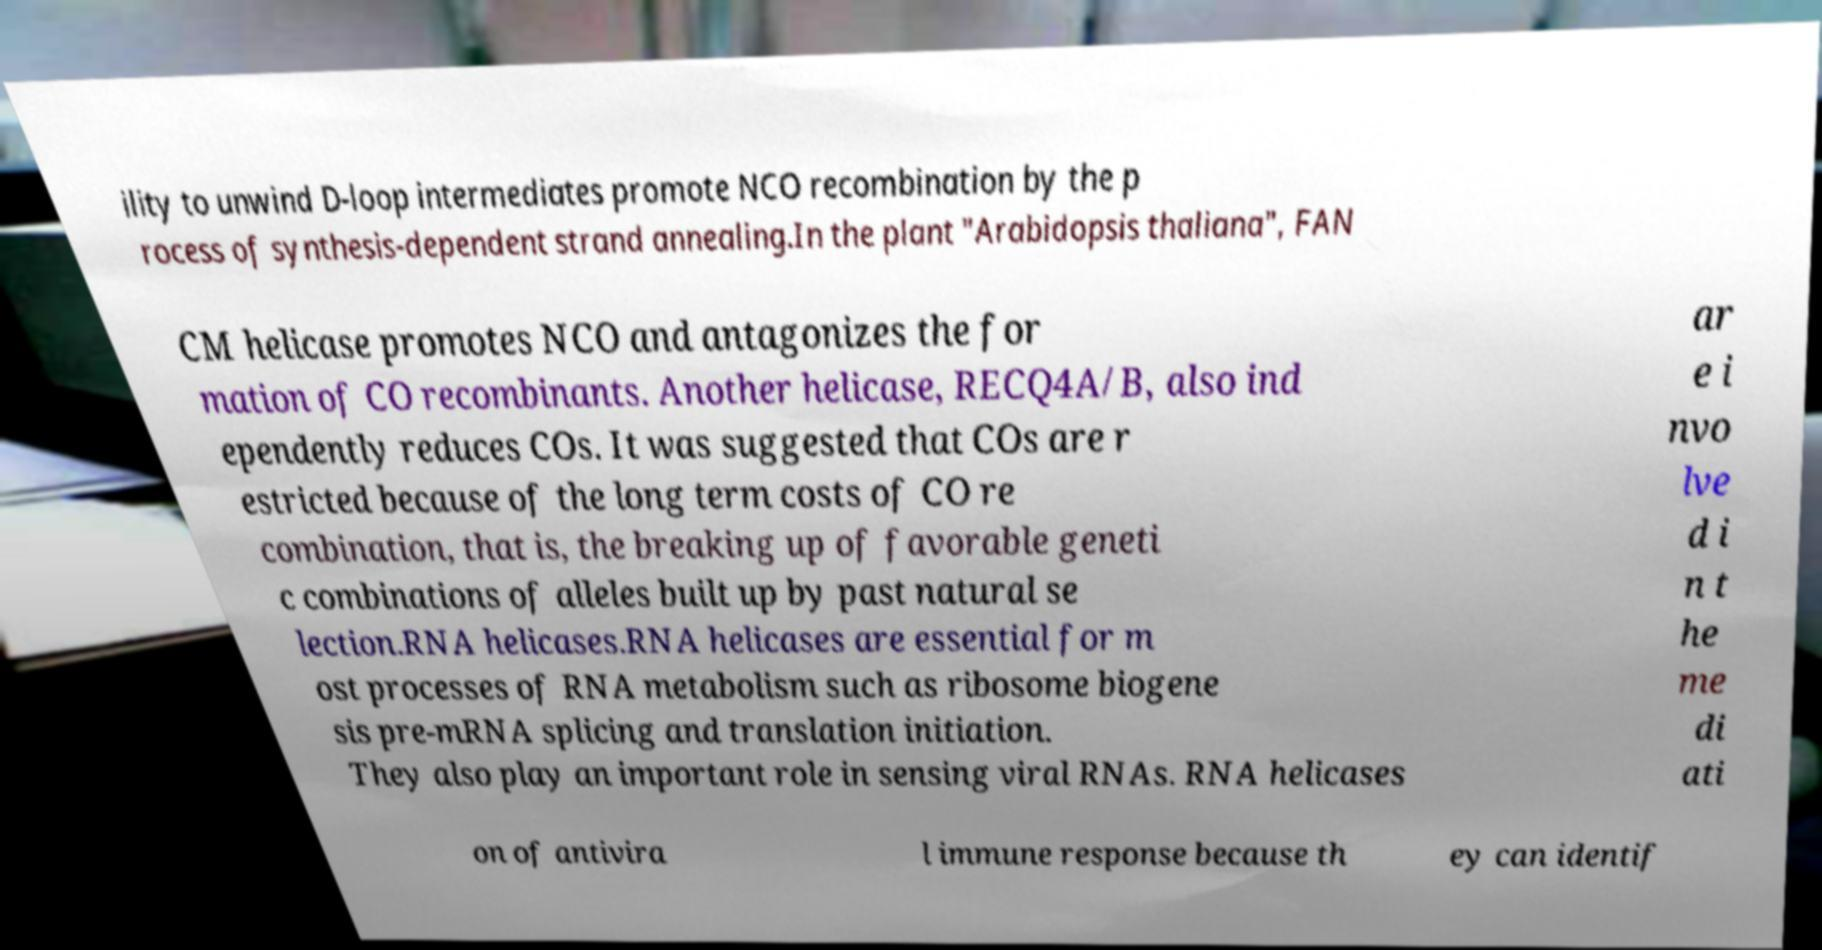Can you read and provide the text displayed in the image?This photo seems to have some interesting text. Can you extract and type it out for me? ility to unwind D-loop intermediates promote NCO recombination by the p rocess of synthesis-dependent strand annealing.In the plant "Arabidopsis thaliana", FAN CM helicase promotes NCO and antagonizes the for mation of CO recombinants. Another helicase, RECQ4A/B, also ind ependently reduces COs. It was suggested that COs are r estricted because of the long term costs of CO re combination, that is, the breaking up of favorable geneti c combinations of alleles built up by past natural se lection.RNA helicases.RNA helicases are essential for m ost processes of RNA metabolism such as ribosome biogene sis pre-mRNA splicing and translation initiation. They also play an important role in sensing viral RNAs. RNA helicases ar e i nvo lve d i n t he me di ati on of antivira l immune response because th ey can identif 